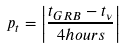Convert formula to latex. <formula><loc_0><loc_0><loc_500><loc_500>p _ { t } = \left | \frac { t _ { G R B } - t _ { \nu } } { 4 h o u r s } \right |</formula> 